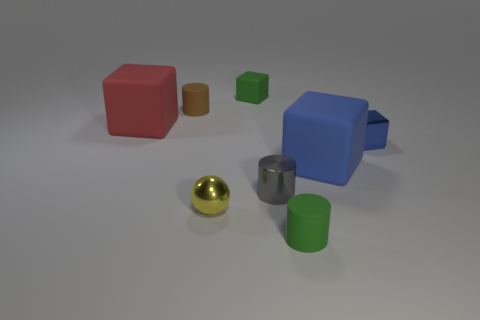Subtract all matte cylinders. How many cylinders are left? 1 Subtract 2 blocks. How many blocks are left? 2 Subtract all cyan blocks. Subtract all purple spheres. How many blocks are left? 4 Add 2 small brown metallic cubes. How many objects exist? 10 Subtract all spheres. How many objects are left? 7 Add 1 red cubes. How many red cubes exist? 2 Subtract 0 red cylinders. How many objects are left? 8 Subtract all brown cylinders. Subtract all green matte cylinders. How many objects are left? 6 Add 1 cylinders. How many cylinders are left? 4 